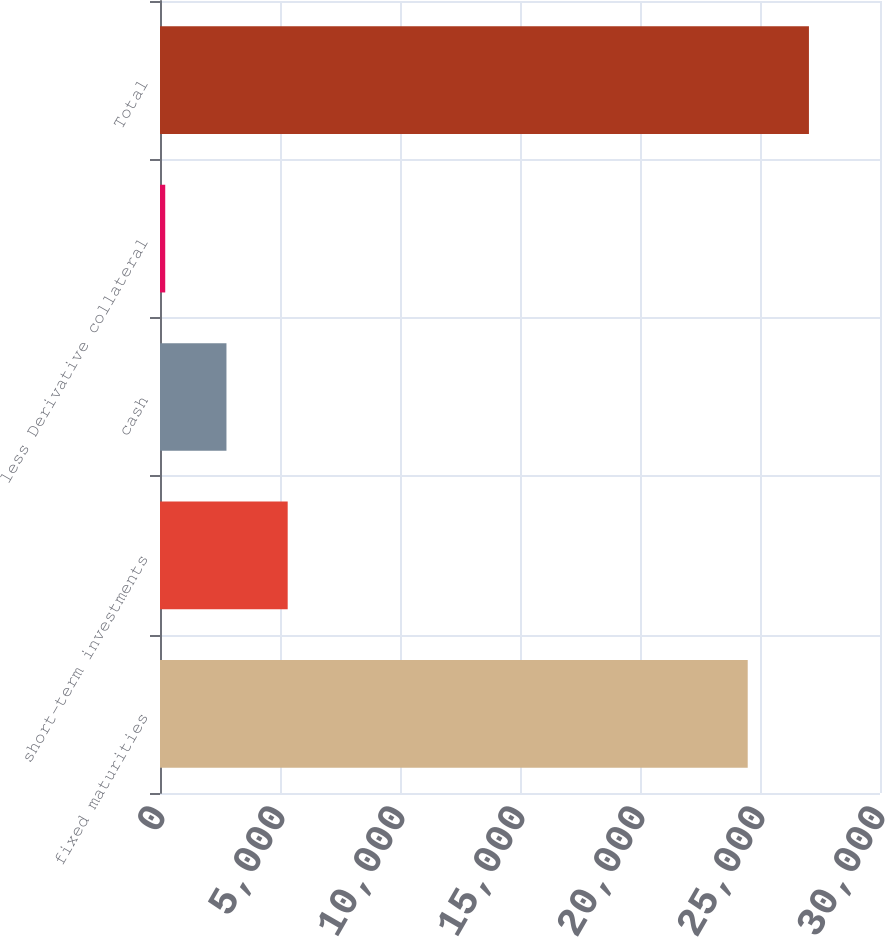<chart> <loc_0><loc_0><loc_500><loc_500><bar_chart><fcel>fixed maturities<fcel>short-term investments<fcel>cash<fcel>less Derivative collateral<fcel>Total<nl><fcel>24488<fcel>5320.4<fcel>2769.2<fcel>218<fcel>27039.2<nl></chart> 